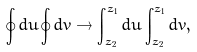Convert formula to latex. <formula><loc_0><loc_0><loc_500><loc_500>\oint d u \oint d \bar { v } \rightarrow \int _ { z _ { 2 } } ^ { z _ { 1 } } d u \int _ { \bar { z } _ { 2 } } ^ { \bar { z } _ { 1 } } d \bar { v } ,</formula> 